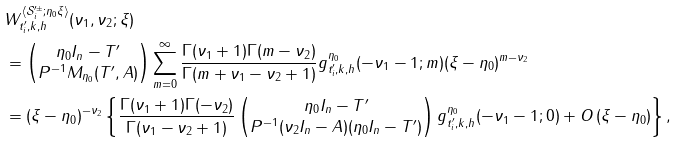Convert formula to latex. <formula><loc_0><loc_0><loc_500><loc_500>& W ^ { \langle \mathcal { S } ^ { \prime \pm } _ { i } ; \eta _ { 0 } \xi \rangle } _ { t ^ { \prime } _ { i } , k , h } ( \nu _ { 1 } , \nu _ { 2 } ; \xi ) \\ & = \begin{pmatrix} \eta _ { 0 } I _ { n } - T ^ { \prime } \\ P ^ { - 1 } M _ { \eta _ { 0 } } ( T ^ { \prime } , A ) \end{pmatrix} \sum _ { m = 0 } ^ { \infty } \frac { \Gamma ( \nu _ { 1 } + 1 ) \Gamma ( m - \nu _ { 2 } ) } { \Gamma ( m + \nu _ { 1 } - \nu _ { 2 } + 1 ) } g ^ { \eta _ { 0 } } _ { t ^ { \prime } _ { i } , k , h } ( - \nu _ { 1 } - 1 ; m ) ( \xi - \eta _ { 0 } ) ^ { m - \nu _ { 2 } } \\ & = ( \xi - \eta _ { 0 } ) ^ { - \nu _ { 2 } } \left \{ \frac { \Gamma ( \nu _ { 1 } + 1 ) \Gamma ( - \nu _ { 2 } ) } { \Gamma ( \nu _ { 1 } - \nu _ { 2 } + 1 ) } \begin{pmatrix} \eta _ { 0 } I _ { n } - T ^ { \prime } \\ P ^ { - 1 } ( \nu _ { 2 } I _ { n } - A ) ( \eta _ { 0 } I _ { n } - T ^ { \prime } ) \end{pmatrix} g ^ { \eta _ { 0 } } _ { t ^ { \prime } _ { i } , k , h } ( - \nu _ { 1 } - 1 ; 0 ) + O \left ( \xi - \eta _ { 0 } \right ) \right \} ,</formula> 